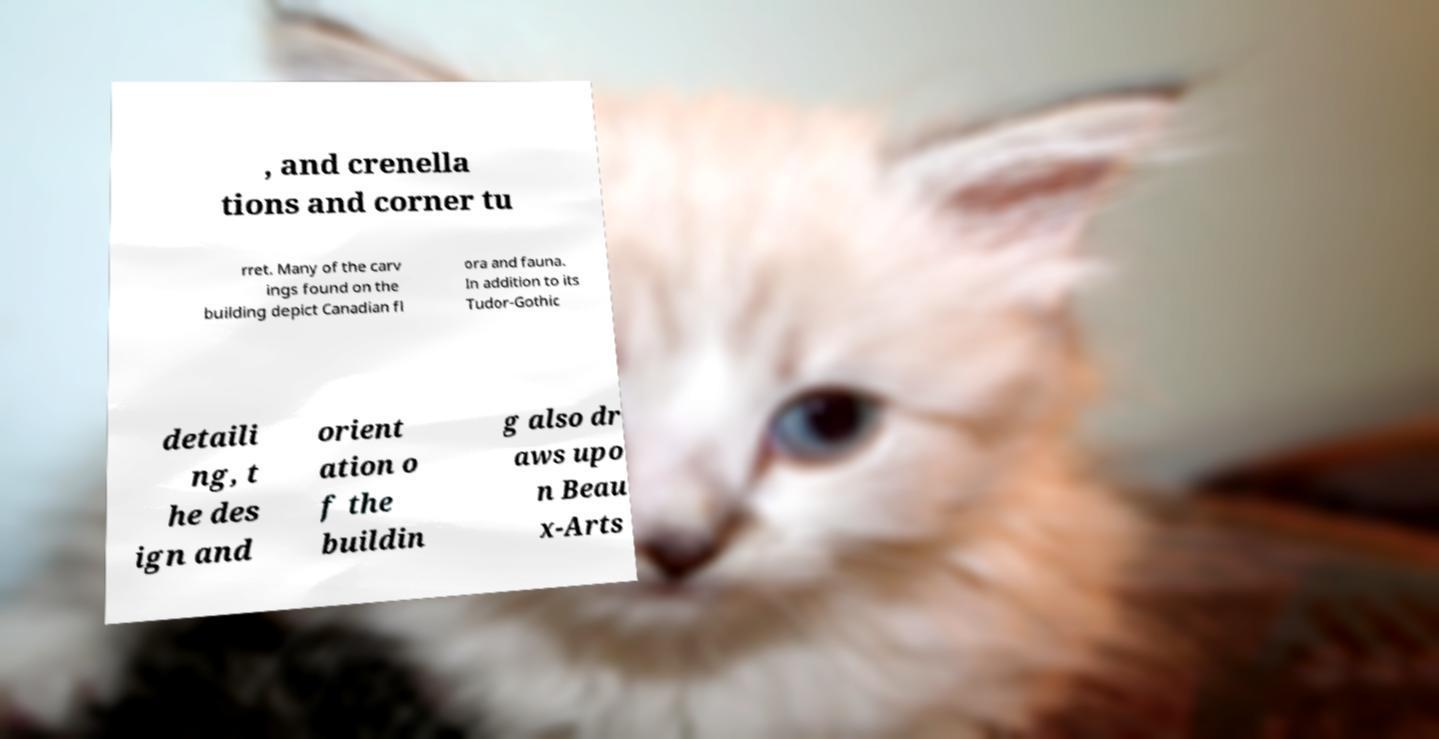What messages or text are displayed in this image? I need them in a readable, typed format. , and crenella tions and corner tu rret. Many of the carv ings found on the building depict Canadian fl ora and fauna. In addition to its Tudor-Gothic detaili ng, t he des ign and orient ation o f the buildin g also dr aws upo n Beau x-Arts 